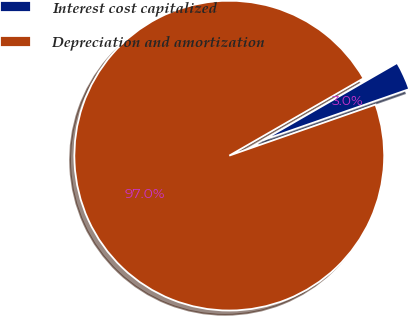Convert chart. <chart><loc_0><loc_0><loc_500><loc_500><pie_chart><fcel>Interest cost capitalized<fcel>Depreciation and amortization<nl><fcel>2.97%<fcel>97.03%<nl></chart> 